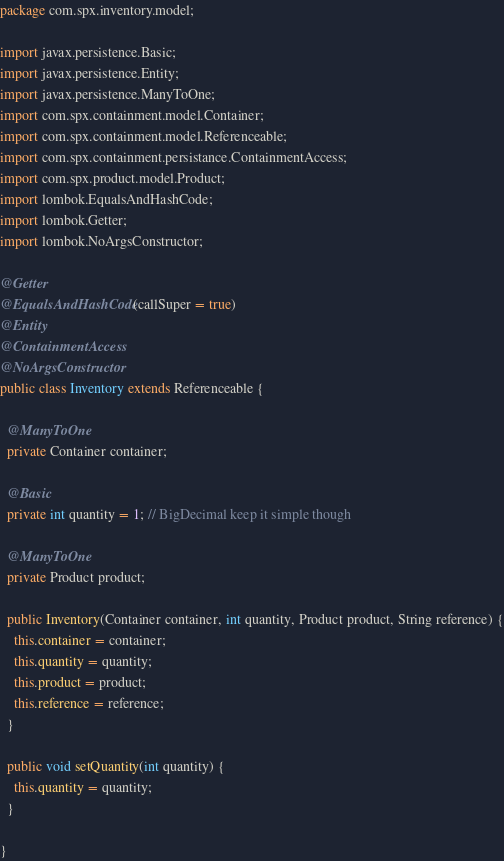Convert code to text. <code><loc_0><loc_0><loc_500><loc_500><_Java_>package com.spx.inventory.model;

import javax.persistence.Basic;
import javax.persistence.Entity;
import javax.persistence.ManyToOne;
import com.spx.containment.model.Container;
import com.spx.containment.model.Referenceable;
import com.spx.containment.persistance.ContainmentAccess;
import com.spx.product.model.Product;
import lombok.EqualsAndHashCode;
import lombok.Getter;
import lombok.NoArgsConstructor;

@Getter
@EqualsAndHashCode(callSuper = true)
@Entity
@ContainmentAccess
@NoArgsConstructor
public class Inventory extends Referenceable {

  @ManyToOne
  private Container container;

  @Basic
  private int quantity = 1; // BigDecimal keep it simple though

  @ManyToOne
  private Product product;

  public Inventory(Container container, int quantity, Product product, String reference) {
    this.container = container;
    this.quantity = quantity;
    this.product = product;
    this.reference = reference;
  }

  public void setQuantity(int quantity) {
    this.quantity = quantity;
  }

}
</code> 